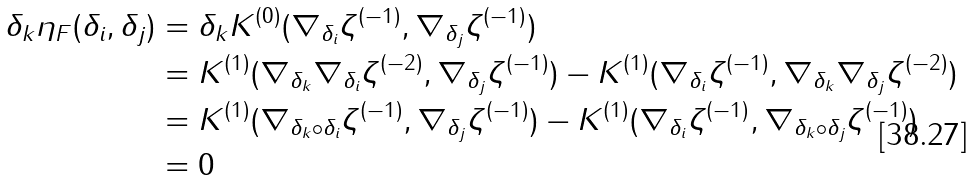Convert formula to latex. <formula><loc_0><loc_0><loc_500><loc_500>\delta _ { k } \eta _ { F } ( \delta _ { i } , \delta _ { j } ) & = \delta _ { k } K ^ { ( 0 ) } ( \nabla _ { \delta _ { i } } \zeta ^ { ( - 1 ) } , \nabla _ { \delta _ { j } } \zeta ^ { ( - 1 ) } ) \\ & = K ^ { ( 1 ) } ( \nabla _ { \delta _ { k } } \nabla _ { \delta _ { i } } \zeta ^ { ( - 2 ) } , \nabla _ { \delta _ { j } } \zeta ^ { ( - 1 ) } ) - K ^ { ( 1 ) } ( \nabla _ { \delta _ { i } } \zeta ^ { ( - 1 ) } , \nabla _ { \delta _ { k } } \nabla _ { \delta _ { j } } \zeta ^ { ( - 2 ) } ) \\ & = K ^ { ( 1 ) } ( \nabla _ { \delta _ { k } \circ \delta _ { i } } \zeta ^ { ( - 1 ) } , \nabla _ { \delta _ { j } } \zeta ^ { ( - 1 ) } ) - K ^ { ( 1 ) } ( \nabla _ { \delta _ { i } } \zeta ^ { ( - 1 ) } , \nabla _ { \delta _ { k } \circ \delta _ { j } } \zeta ^ { ( - 1 ) } ) \\ & = 0</formula> 